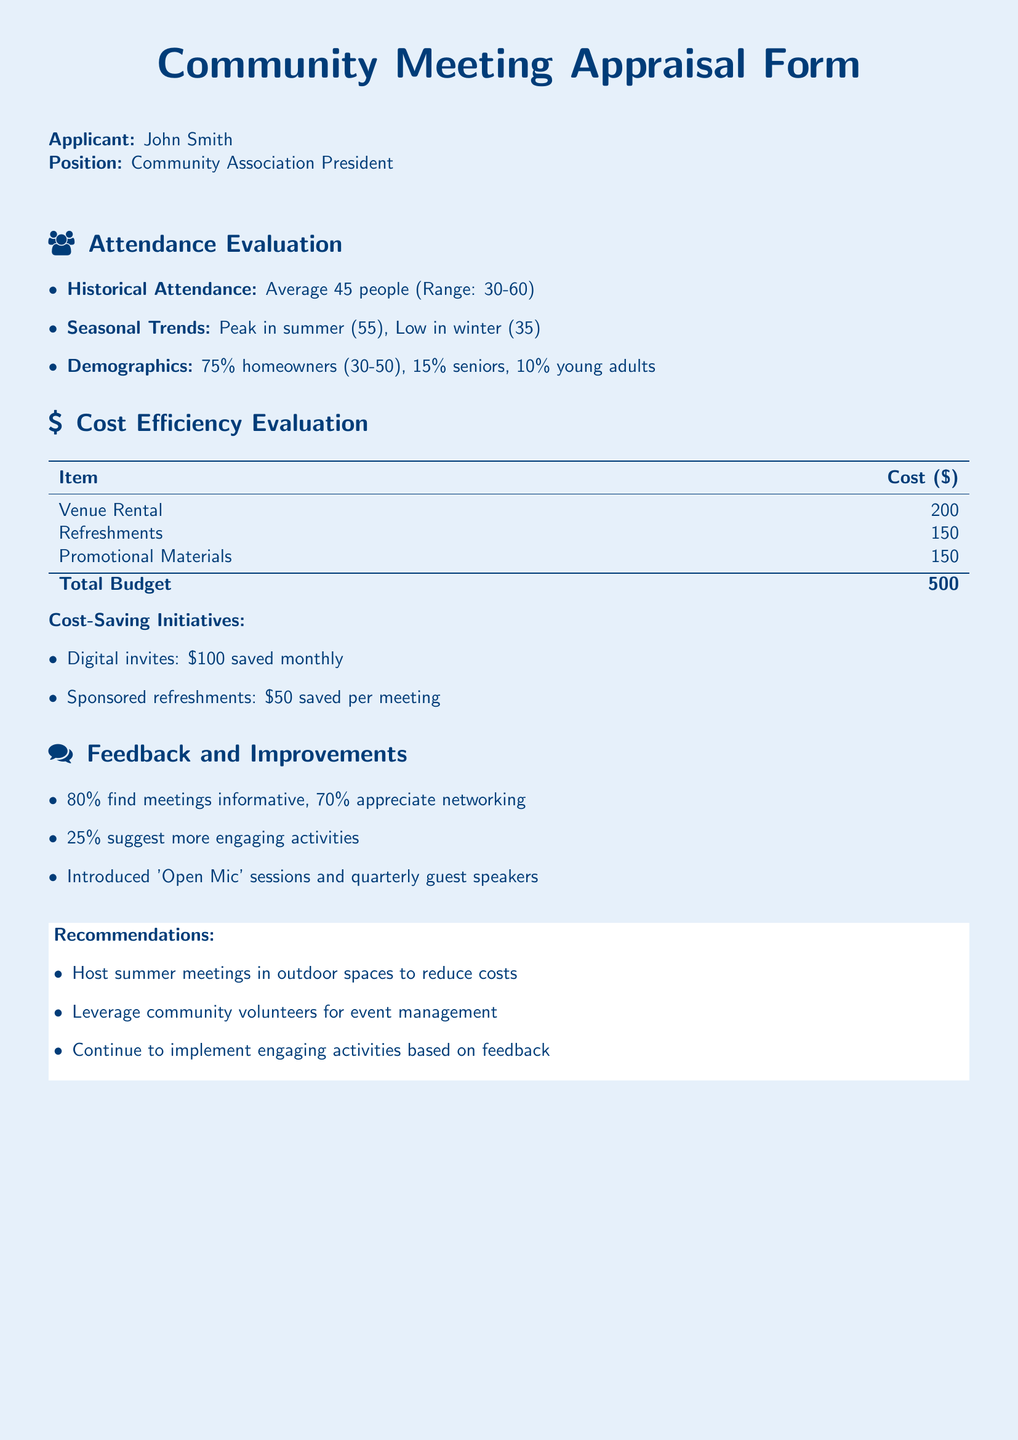What is the average attendance at the meetings? The average attendance is a specific number mentioned in the document, which is 45 people.
Answer: 45 people What is the peak attendance month? The document mentions seasonal trends, identifying the peak attendance in summer.
Answer: summer What percentage of attendees are homeowners? The percentage of homeowners is listed under demographics, which is 75%.
Answer: 75% What is the total budget for the community meetings? The total budget is calculated in the Cost Efficiency Evaluation section, summing up the costs.
Answer: 500 How much is saved by using digital invites? The savings from digital invites is stated in the cost-saving initiatives section, which is $100.
Answer: 100 How many attendees appreciate networking? The feedback section mentions that 70% of attendees appreciate networking.
Answer: 70% What is one of the suggested improvements based on feedback? The feedback section includes suggestions for more engaging activities as an improvement.
Answer: more engaging activities What is the cost of refreshments for a meeting? The cost of refreshments is specified under the Cost Efficiency Evaluation section, which is $150.
Answer: 150 What is a recommended initiative to reduce costs? The recommendations section suggests hosting summer meetings in outdoor spaces to reduce costs.
Answer: outdoor spaces 